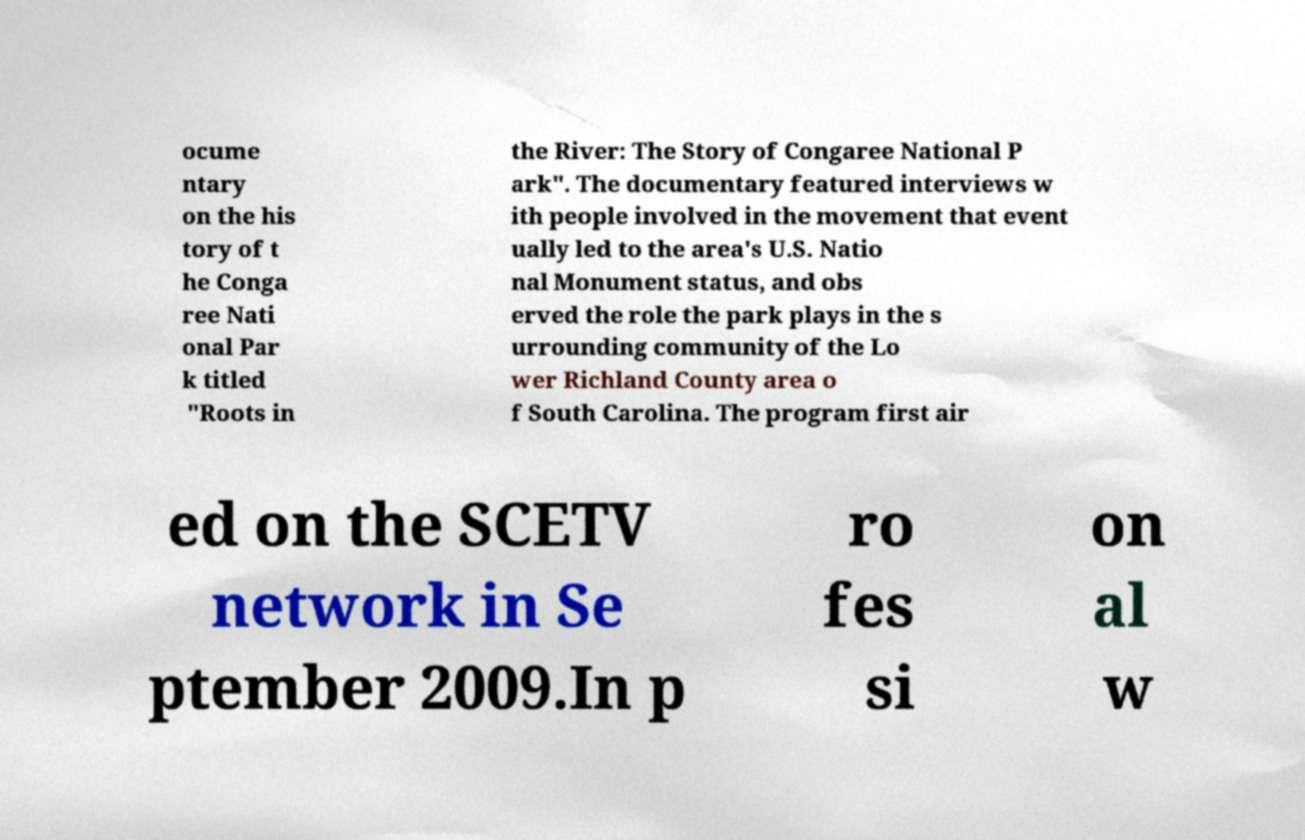I need the written content from this picture converted into text. Can you do that? ocume ntary on the his tory of t he Conga ree Nati onal Par k titled "Roots in the River: The Story of Congaree National P ark". The documentary featured interviews w ith people involved in the movement that event ually led to the area's U.S. Natio nal Monument status, and obs erved the role the park plays in the s urrounding community of the Lo wer Richland County area o f South Carolina. The program first air ed on the SCETV network in Se ptember 2009.In p ro fes si on al w 